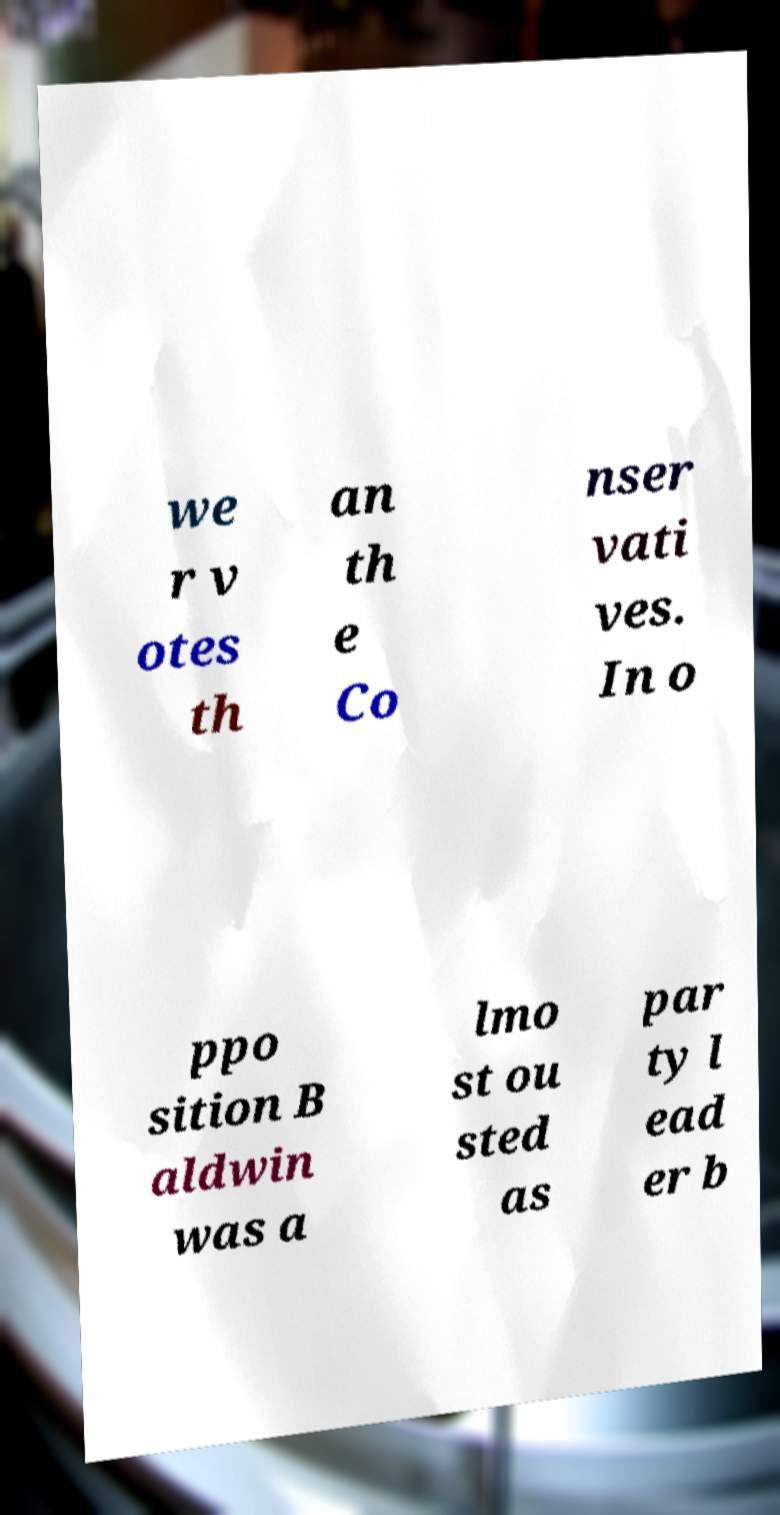Can you accurately transcribe the text from the provided image for me? we r v otes th an th e Co nser vati ves. In o ppo sition B aldwin was a lmo st ou sted as par ty l ead er b 